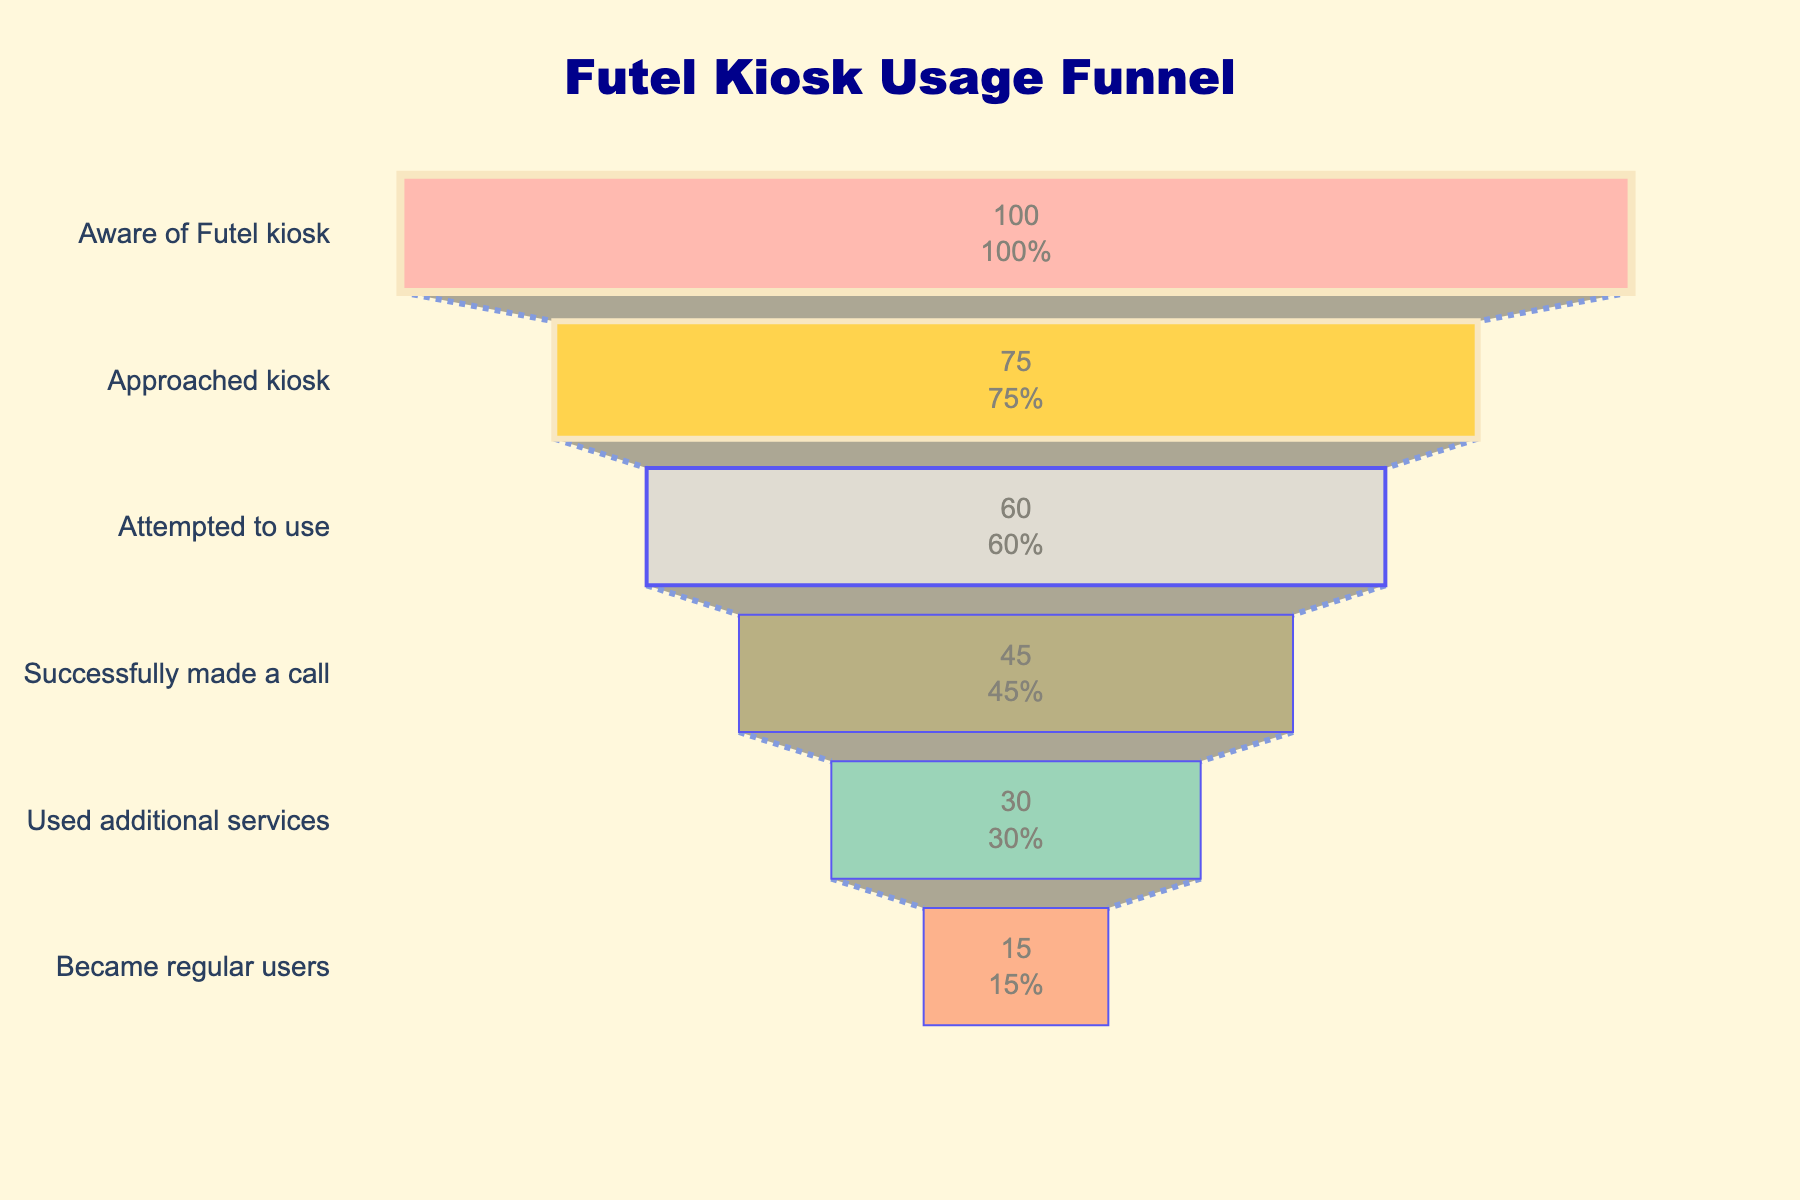How many total users are aware of the Futel kiosk? The first step in the funnel, titled "Aware of Futel kiosk", lists the total users as 1000.
Answer: 1000 How many users successfully made a call? The third step, "Successfully made a call", lists the total number of users as 450.
Answer: 450 What percentage of users who approached the kiosk attempted to use it? "Approached kiosk" has 750 users and "Attempted to use" has 600. The percentage is calculated by (600 / 750) * 100.
Answer: 80% What is the drop-off percentage from users who attempted to use the kiosk to those who successfully made a call? "Attempted to use" is 600 and "Successfully made a call" is 450. The drop-off is calculated as (600 - 450) / 600 * 100.
Answer: 25% How many regular users came from those who used additional services? "Used additional services" is 300 and "Became regular users" is 150. Since these steps are sequential, the number of regular users equals the number of users who became regular after using additional services.
Answer: 150 What is the biggest drop in user percentage between successive steps? Comparing the percentages from step-to-step: 25% from "Aware" to "Approached", 15% from "Approached" to "Attempted", 15% from "Attempted" to "Successfully made a call", 15% from "Successfully made a call" to "Used additional services", and 15% from "Used additional services" to "Became regular users". The biggest drop is 25%.
Answer: 25% What step has the lowest percentage conversion from the previous step? The drop from "Aware of Futel kiosk" (100%) to "Approached kiosk" (75%) is the largest single drop, making the conversion rate here the smallest one.
Answer: Approached kiosk Which user demographic uses additional services the most? "Used additional services" is the step with the title and total percentage is 30% from the funnel. The user demographic that uses additional services can be inferred from this step.
Answer: 30% What is the ratio of users who successfully made a call to those who became regular users? "Successfully made a call" has 450 users, "Became regular users" has 150. The ratio is 450:150, which simplifies to 3:1.
Answer: 3:1 How many more users attempted to use the kiosk than those who became regular users? "Attempted to use" is 600 and "Became regular users" is 150. The difference is calculated as 600 - 150.
Answer: 450 